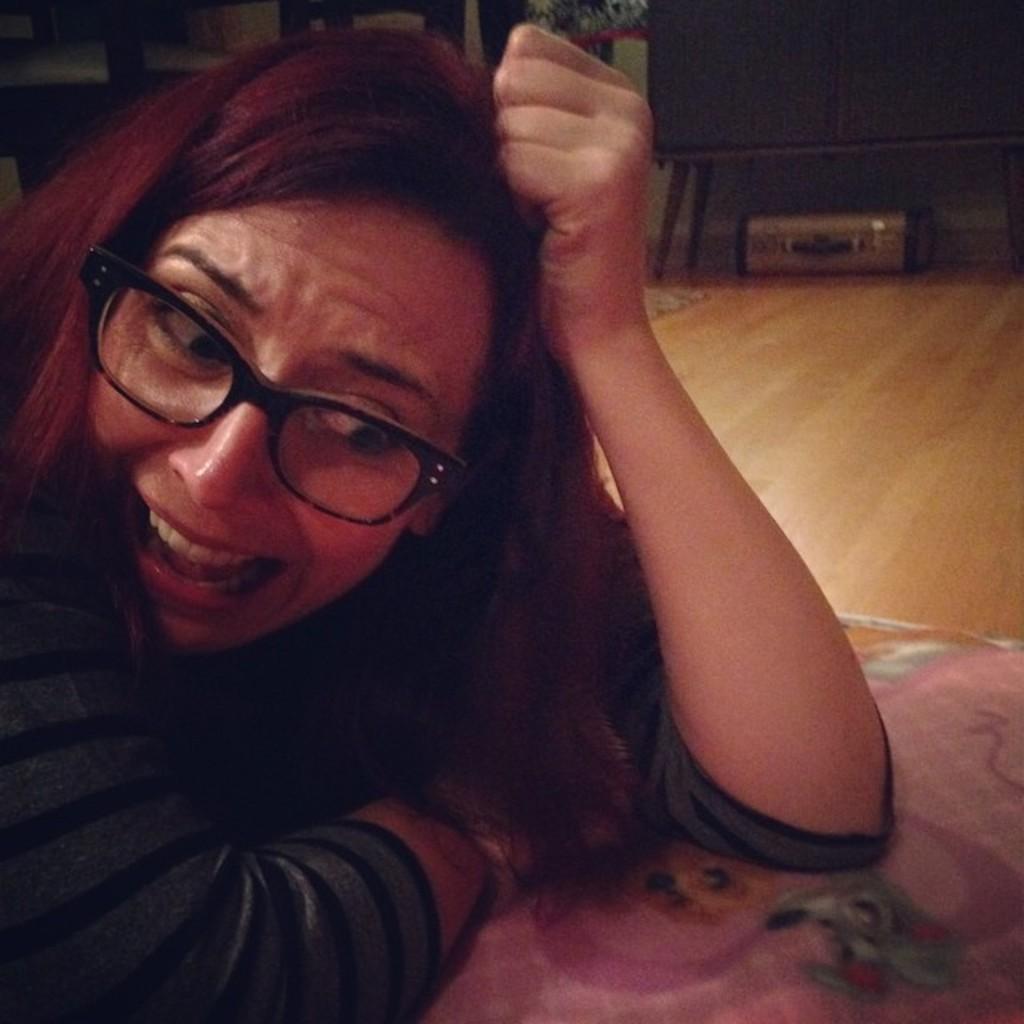Can you describe this image briefly? In this picture I can see a woman in front, who is wearing spectacle. In the background I can see the floor and I see a suitcase and above it, I see a brown color thing. 